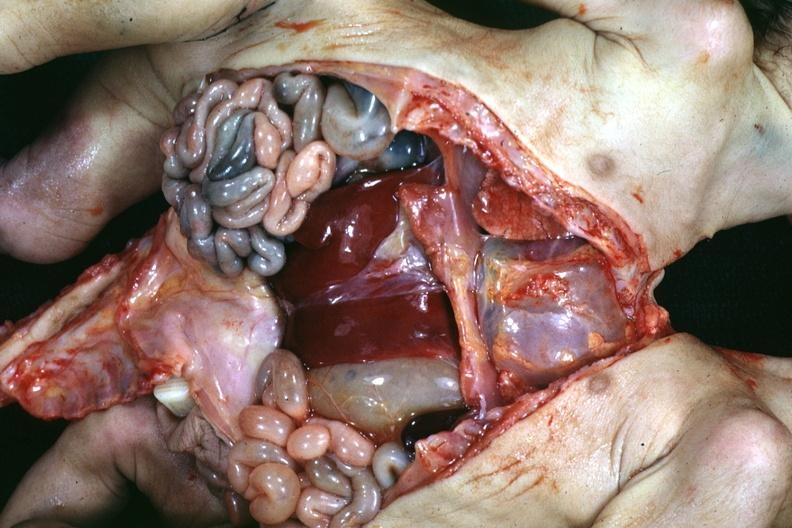what does this image show?
Answer the question using a single word or phrase. Joined lower chest and abdomen anterior opened lower chest and abdomen showing apparent two sets intestine with one liver 